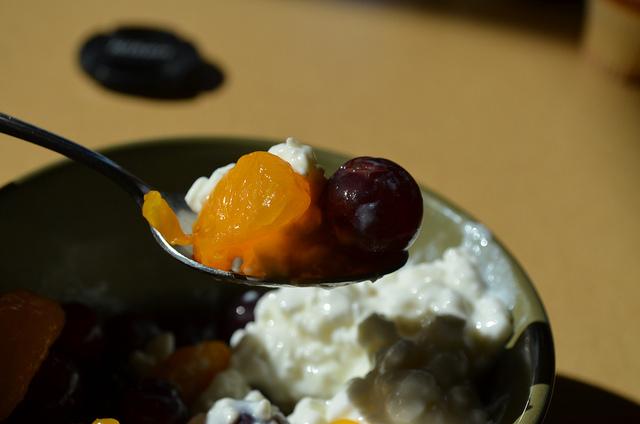Is this edible?
Answer briefly. Yes. What kind of dish is that?
Concise answer only. Dessert. Did part of this meal come from a cow?
Keep it brief. Yes. 